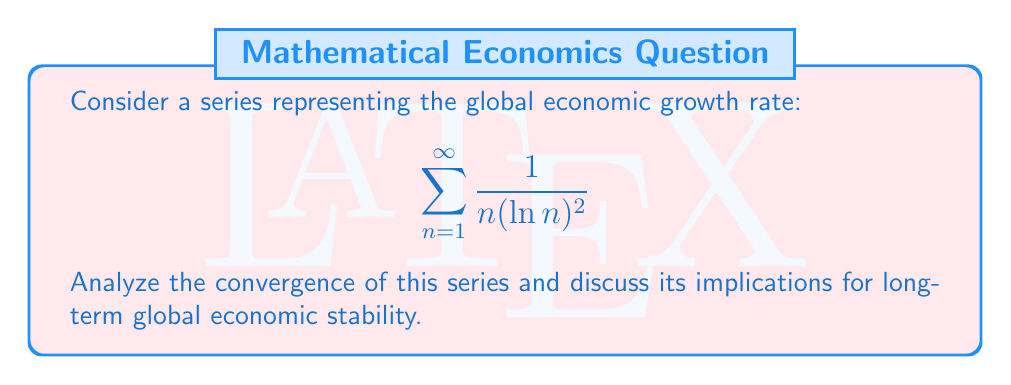Show me your answer to this math problem. To analyze the convergence of this series, we'll use the integral test:

Step 1: Let $f(x) = \frac{1}{x(\ln x)^2}$. This function is positive and decreasing for $x \geq 3$.

Step 2: We'll evaluate the improper integral:

$$\int_3^{\infty} \frac{1}{x(\ln x)^2} dx$$

Step 3: Substitute $u = \ln x$, so $du = \frac{1}{x} dx$:

$$\int_{\ln 3}^{\infty} \frac{1}{u^2} du$$

Step 4: Evaluate the integral:

$$\left[-\frac{1}{u}\right]_{\ln 3}^{\infty} = 0 - \left(-\frac{1}{\ln 3}\right) = \frac{1}{\ln 3}$$

Step 5: Since the integral converges to a finite value, by the integral test, the series also converges.

Implications for global economic stability:
The convergence of this series suggests that while global economic growth rates may fluctuate, they tend to stabilize over time. This implies a long-term trend towards economic equilibrium, where extreme fluctuations become less frequent. For international relations, this indicates that diplomatic strategies should focus on long-term economic cooperation and stability rather than short-term gains.
Answer: The series converges, implying long-term global economic stabilization. 